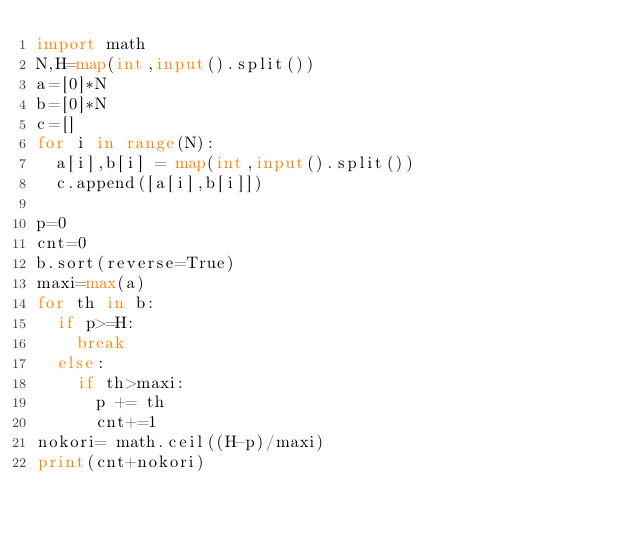Convert code to text. <code><loc_0><loc_0><loc_500><loc_500><_Python_>import math
N,H=map(int,input().split())
a=[0]*N
b=[0]*N
c=[]
for i in range(N):
  a[i],b[i] = map(int,input().split())
  c.append([a[i],b[i]])
  
p=0
cnt=0
b.sort(reverse=True)
maxi=max(a)
for th in b:
  if p>=H:
    break
  else:
    if th>maxi:
      p += th
      cnt+=1
nokori= math.ceil((H-p)/maxi)
print(cnt+nokori)</code> 